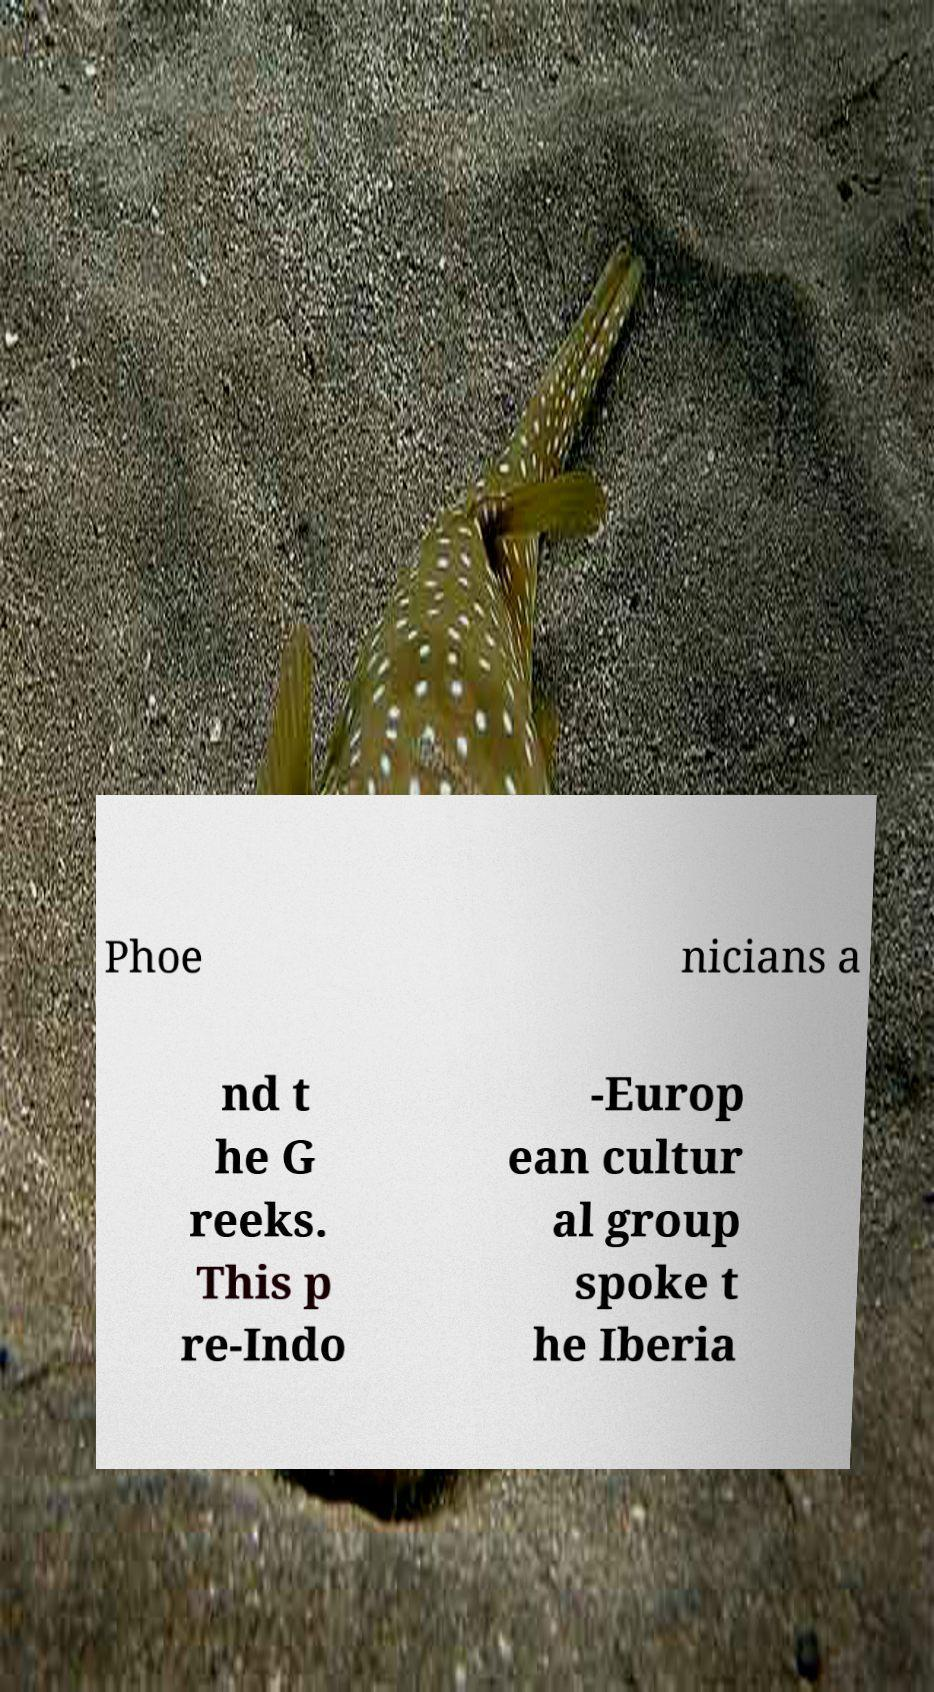For documentation purposes, I need the text within this image transcribed. Could you provide that? Phoe nicians a nd t he G reeks. This p re-Indo -Europ ean cultur al group spoke t he Iberia 